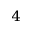<formula> <loc_0><loc_0><loc_500><loc_500>^ { 4 }</formula> 